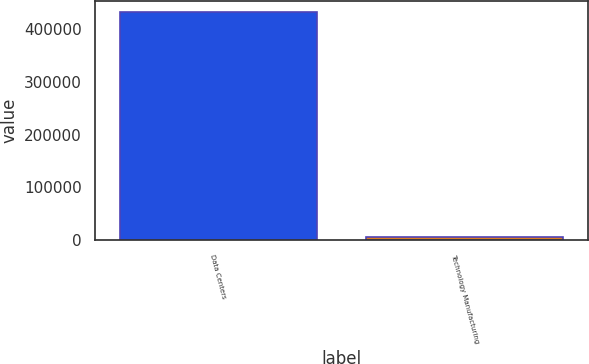<chart> <loc_0><loc_0><loc_500><loc_500><bar_chart><fcel>Data Centers<fcel>Technology Manufacturing<nl><fcel>431444<fcel>6333<nl></chart> 